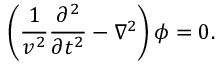Convert formula to latex. <formula><loc_0><loc_0><loc_500><loc_500>\left ( \frac { 1 } { v ^ { 2 } } \frac { \partial ^ { 2 } } { \partial t ^ { 2 } } - \nabla ^ { 2 } \right ) \phi = 0 .</formula> 